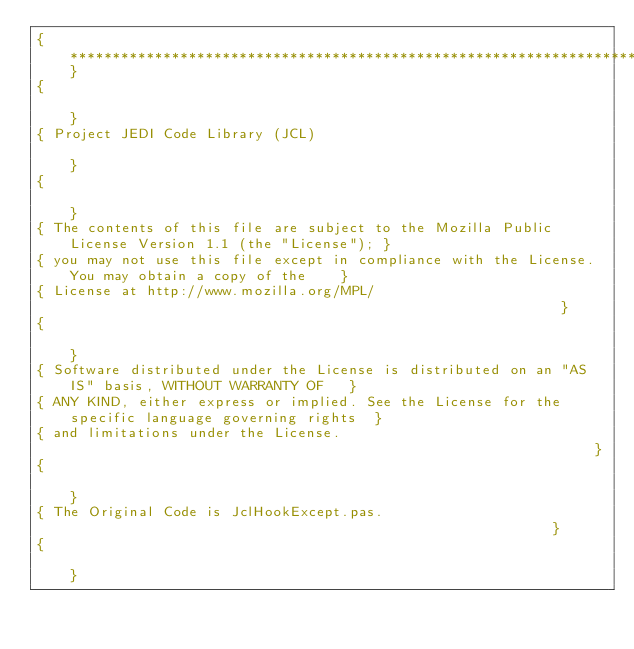<code> <loc_0><loc_0><loc_500><loc_500><_Pascal_>{**************************************************************************************************}
{                                                                                                  }
{ Project JEDI Code Library (JCL)                                                                  }
{                                                                                                  }
{ The contents of this file are subject to the Mozilla Public License Version 1.1 (the "License"); }
{ you may not use this file except in compliance with the License. You may obtain a copy of the    }
{ License at http://www.mozilla.org/MPL/                                                           }
{                                                                                                  }
{ Software distributed under the License is distributed on an "AS IS" basis, WITHOUT WARRANTY OF   }
{ ANY KIND, either express or implied. See the License for the specific language governing rights  }
{ and limitations under the License.                                                               }
{                                                                                                  }
{ The Original Code is JclHookExcept.pas.                                                          }
{                                                                                                  }</code> 